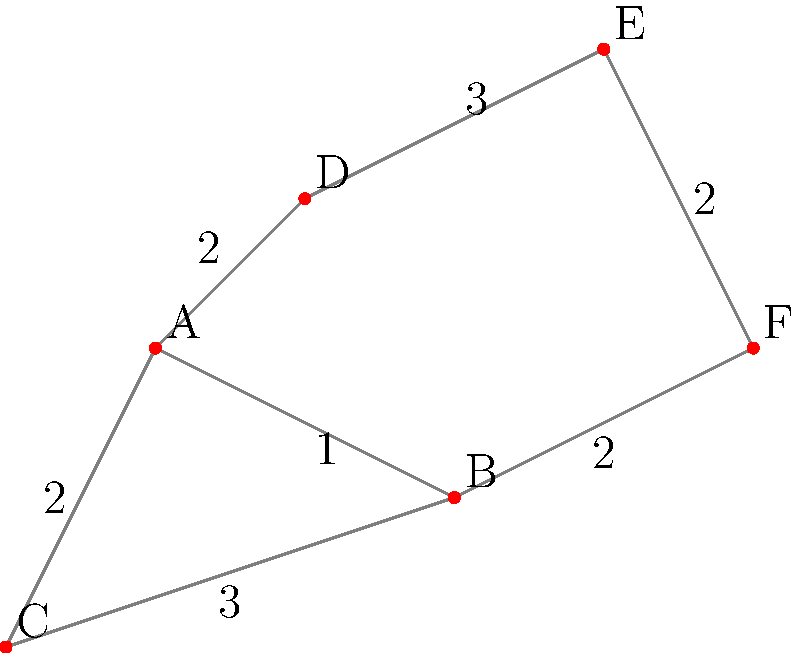You're designing a network of solar panels for your off-grid cabin using a minimum spanning tree approach. The cabin (C) and potential solar panel locations (A, B, D, E, F) are shown in the diagram, with distances between locations represented by edge weights. What is the total length of cable needed to connect all locations in the most efficient manner? To find the most efficient way to connect all locations, we need to determine the minimum spanning tree of the given graph. We can use Kruskal's algorithm to find this:

1. Sort all edges by weight in ascending order:
   (A,B): 1
   (C,A), (B,F), (E,F): 2
   (C,B), (D,E): 3

2. Start with an empty set of edges and add edges in order, skipping those that would create a cycle:
   - Add (A,B): 1
   - Add (C,A): 2
   - Add (B,F): 2
   - Add (D,E): 3

3. All locations are now connected with 4 edges.

4. Sum the weights of the selected edges:
   $1 + 2 + 2 + 3 = 8$

Therefore, the total length of cable needed is 8 units.
Answer: 8 units 